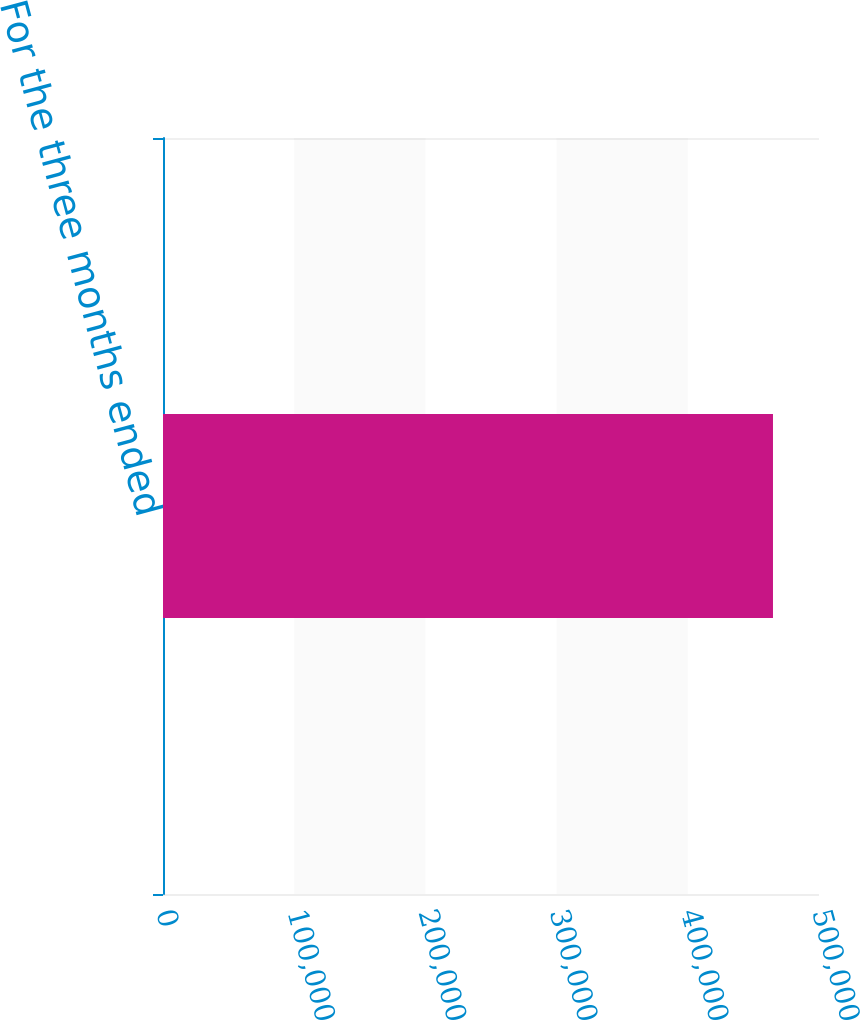Convert chart. <chart><loc_0><loc_0><loc_500><loc_500><bar_chart><fcel>For the three months ended<nl><fcel>464924<nl></chart> 